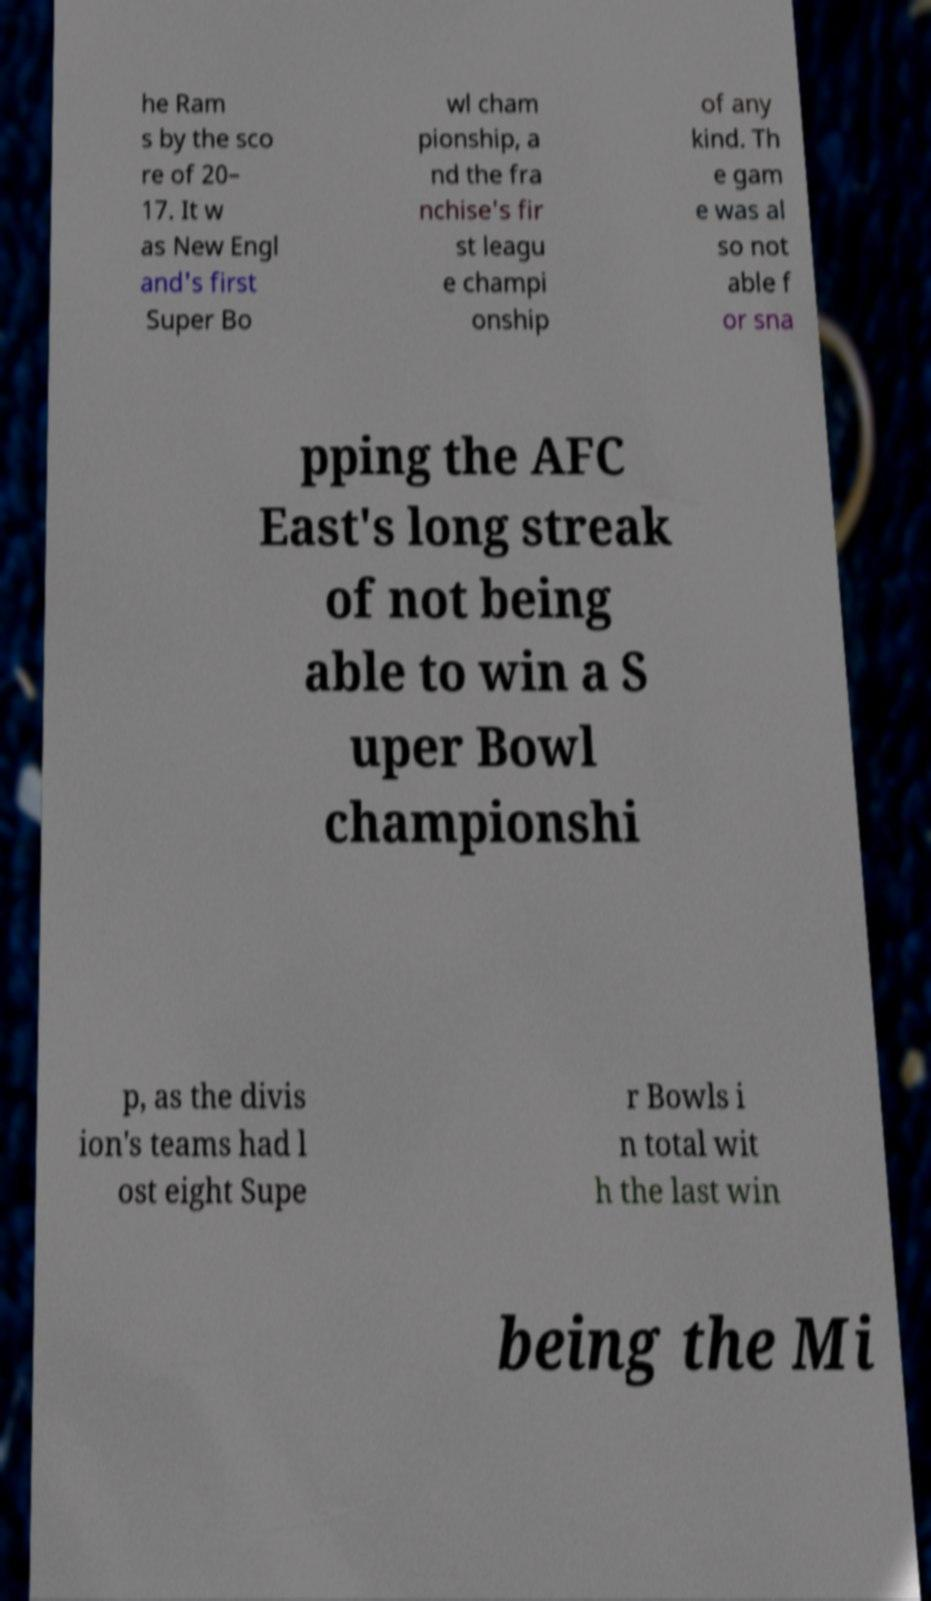Please read and relay the text visible in this image. What does it say? he Ram s by the sco re of 20– 17. It w as New Engl and's first Super Bo wl cham pionship, a nd the fra nchise's fir st leagu e champi onship of any kind. Th e gam e was al so not able f or sna pping the AFC East's long streak of not being able to win a S uper Bowl championshi p, as the divis ion's teams had l ost eight Supe r Bowls i n total wit h the last win being the Mi 